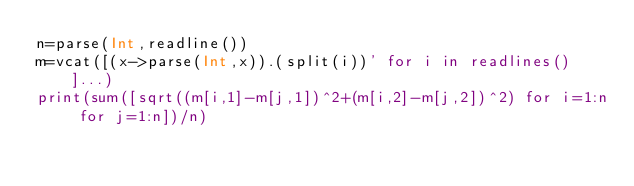Convert code to text. <code><loc_0><loc_0><loc_500><loc_500><_Julia_>n=parse(Int,readline())
m=vcat([(x->parse(Int,x)).(split(i))' for i in readlines()]...)
print(sum([sqrt((m[i,1]-m[j,1])^2+(m[i,2]-m[j,2])^2) for i=1:n for j=1:n])/n)</code> 